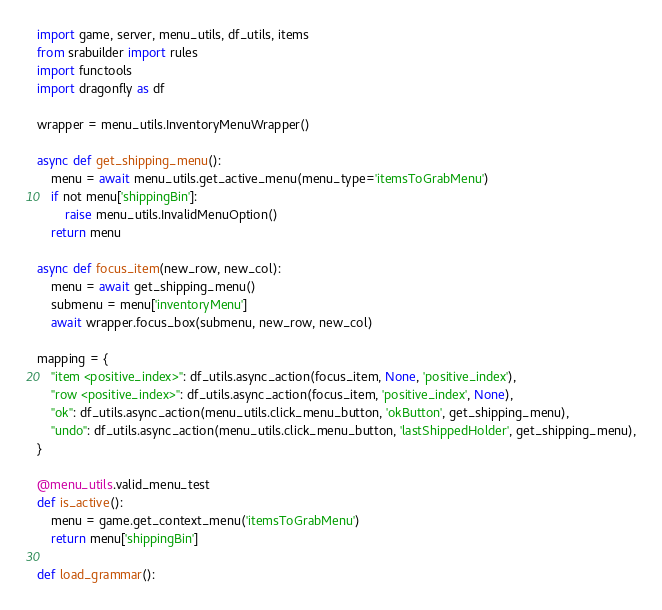<code> <loc_0><loc_0><loc_500><loc_500><_Python_>import game, server, menu_utils, df_utils, items
from srabuilder import rules
import functools
import dragonfly as df

wrapper = menu_utils.InventoryMenuWrapper()

async def get_shipping_menu():
    menu = await menu_utils.get_active_menu(menu_type='itemsToGrabMenu')
    if not menu['shippingBin']:
        raise menu_utils.InvalidMenuOption()
    return menu

async def focus_item(new_row, new_col):
    menu = await get_shipping_menu()
    submenu = menu['inventoryMenu']
    await wrapper.focus_box(submenu, new_row, new_col)

mapping = {
    "item <positive_index>": df_utils.async_action(focus_item, None, 'positive_index'),
    "row <positive_index>": df_utils.async_action(focus_item, 'positive_index', None),
    "ok": df_utils.async_action(menu_utils.click_menu_button, 'okButton', get_shipping_menu),
    "undo": df_utils.async_action(menu_utils.click_menu_button, 'lastShippedHolder', get_shipping_menu),
}

@menu_utils.valid_menu_test
def is_active():
    menu = game.get_context_menu('itemsToGrabMenu')
    return menu['shippingBin']

def load_grammar():</code> 